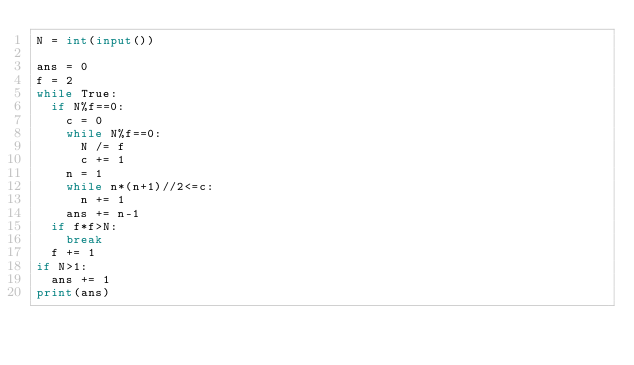Convert code to text. <code><loc_0><loc_0><loc_500><loc_500><_Python_>N = int(input())
 
ans = 0
f = 2
while True:
  if N%f==0:
    c = 0
    while N%f==0:
      N /= f
      c += 1
    n = 1
    while n*(n+1)//2<=c:
      n += 1
    ans += n-1
  if f*f>N:
    break
  f += 1
if N>1:
  ans += 1
print(ans)</code> 